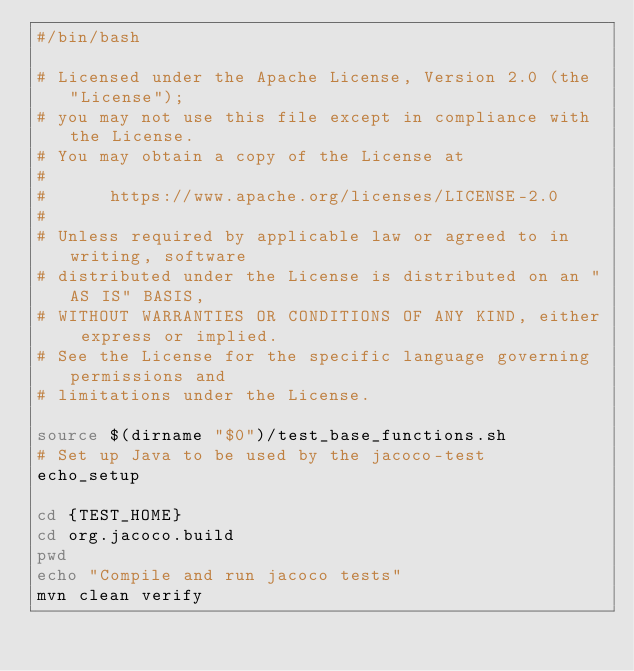Convert code to text. <code><loc_0><loc_0><loc_500><loc_500><_Bash_>#/bin/bash

# Licensed under the Apache License, Version 2.0 (the "License");
# you may not use this file except in compliance with the License.
# You may obtain a copy of the License at
#
#      https://www.apache.org/licenses/LICENSE-2.0
#
# Unless required by applicable law or agreed to in writing, software
# distributed under the License is distributed on an "AS IS" BASIS,
# WITHOUT WARRANTIES OR CONDITIONS OF ANY KIND, either express or implied.
# See the License for the specific language governing permissions and
# limitations under the License.

source $(dirname "$0")/test_base_functions.sh
# Set up Java to be used by the jacoco-test
echo_setup

cd {TEST_HOME}
cd org.jacoco.build
pwd
echo "Compile and run jacoco tests"
mvn clean verify</code> 